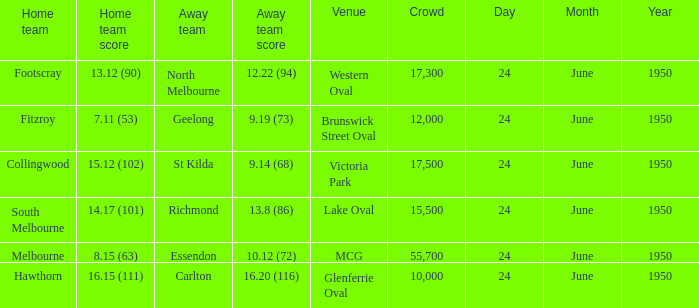Who was the home team for the game where North Melbourne was the away team and the crowd was over 12,000? Footscray. 